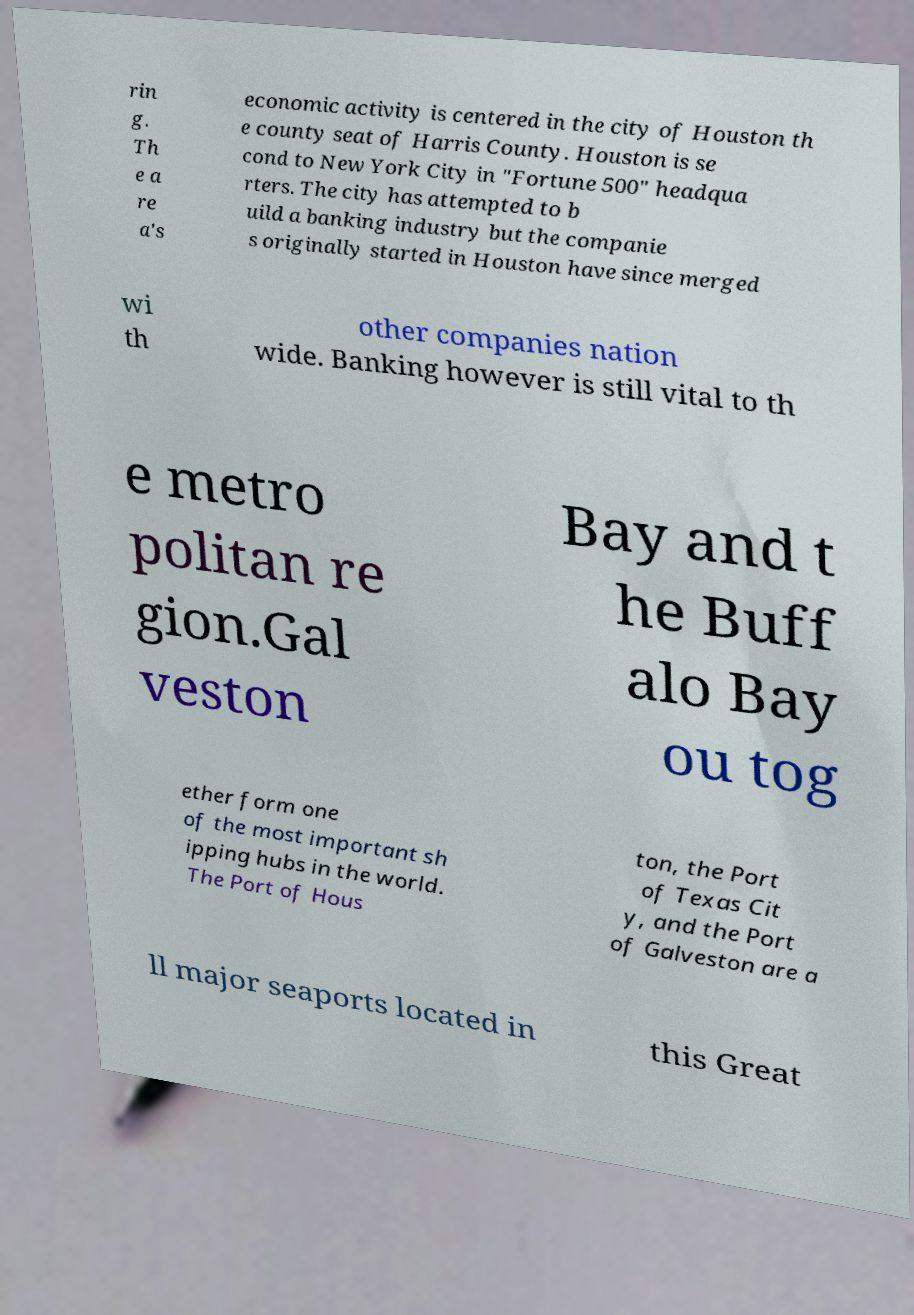Can you accurately transcribe the text from the provided image for me? rin g. Th e a re a's economic activity is centered in the city of Houston th e county seat of Harris County. Houston is se cond to New York City in "Fortune 500" headqua rters. The city has attempted to b uild a banking industry but the companie s originally started in Houston have since merged wi th other companies nation wide. Banking however is still vital to th e metro politan re gion.Gal veston Bay and t he Buff alo Bay ou tog ether form one of the most important sh ipping hubs in the world. The Port of Hous ton, the Port of Texas Cit y, and the Port of Galveston are a ll major seaports located in this Great 